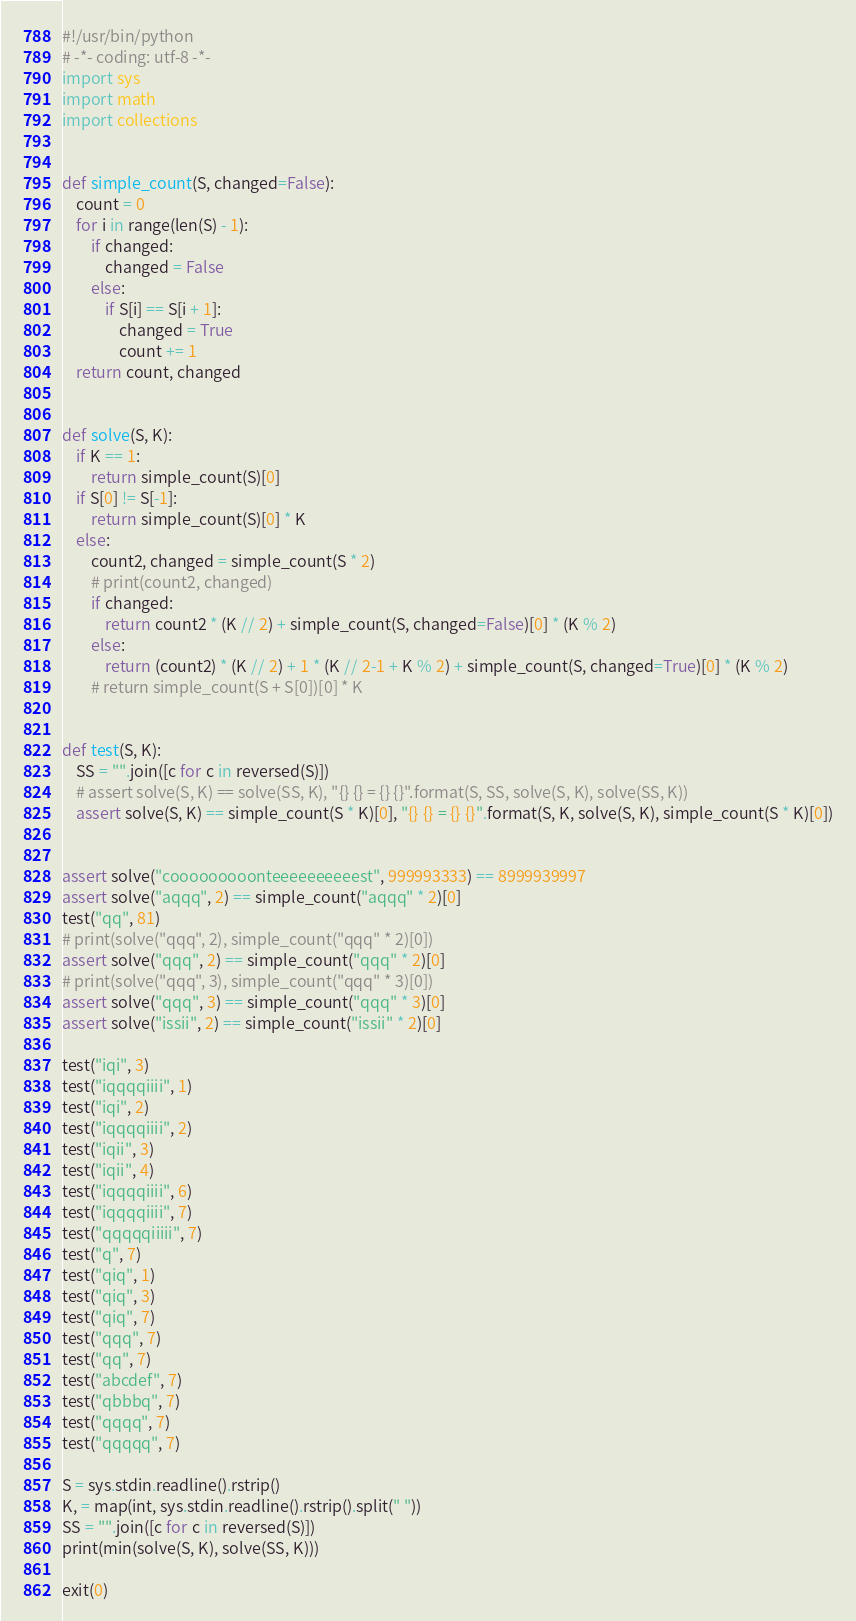<code> <loc_0><loc_0><loc_500><loc_500><_Python_>#!/usr/bin/python
# -*- coding: utf-8 -*-
import sys
import math
import collections


def simple_count(S, changed=False):
    count = 0
    for i in range(len(S) - 1):
        if changed:
            changed = False
        else:
            if S[i] == S[i + 1]:
                changed = True
                count += 1
    return count, changed


def solve(S, K):
    if K == 1:
        return simple_count(S)[0]
    if S[0] != S[-1]:
        return simple_count(S)[0] * K
    else:
        count2, changed = simple_count(S * 2)
        # print(count2, changed)
        if changed:
            return count2 * (K // 2) + simple_count(S, changed=False)[0] * (K % 2)
        else:
            return (count2) * (K // 2) + 1 * (K // 2-1 + K % 2) + simple_count(S, changed=True)[0] * (K % 2)
        # return simple_count(S + S[0])[0] * K


def test(S, K):
    SS = "".join([c for c in reversed(S)])
    # assert solve(S, K) == solve(SS, K), "{} {} = {} {}".format(S, SS, solve(S, K), solve(SS, K))
    assert solve(S, K) == simple_count(S * K)[0], "{} {} = {} {}".format(S, K, solve(S, K), simple_count(S * K)[0])


assert solve("cooooooooonteeeeeeeeeest", 999993333) == 8999939997
assert solve("aqqq", 2) == simple_count("aqqq" * 2)[0]
test("qq", 81)
# print(solve("qqq", 2), simple_count("qqq" * 2)[0])
assert solve("qqq", 2) == simple_count("qqq" * 2)[0]
# print(solve("qqq", 3), simple_count("qqq" * 3)[0])
assert solve("qqq", 3) == simple_count("qqq" * 3)[0]
assert solve("issii", 2) == simple_count("issii" * 2)[0]

test("iqi", 3)
test("iqqqqiiii", 1)
test("iqi", 2)
test("iqqqqiiii", 2)
test("iqii", 3)
test("iqii", 4)
test("iqqqqiiii", 6)
test("iqqqqiiii", 7)
test("qqqqqiiiii", 7)
test("q", 7)
test("qiq", 1)
test("qiq", 3)
test("qiq", 7)
test("qqq", 7)
test("qq", 7)
test("abcdef", 7)
test("qbbbq", 7)
test("qqqq", 7)
test("qqqqq", 7)

S = sys.stdin.readline().rstrip()
K, = map(int, sys.stdin.readline().rstrip().split(" "))
SS = "".join([c for c in reversed(S)])
print(min(solve(S, K), solve(SS, K)))

exit(0)
</code> 